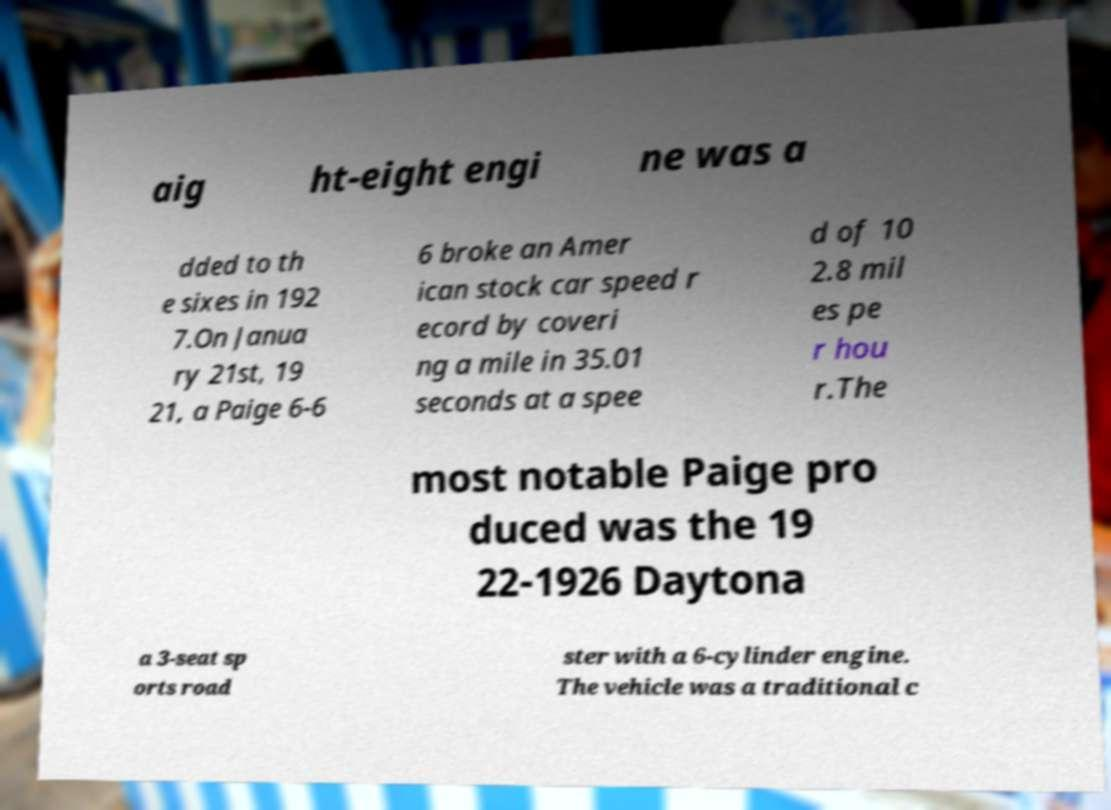Could you assist in decoding the text presented in this image and type it out clearly? aig ht-eight engi ne was a dded to th e sixes in 192 7.On Janua ry 21st, 19 21, a Paige 6-6 6 broke an Amer ican stock car speed r ecord by coveri ng a mile in 35.01 seconds at a spee d of 10 2.8 mil es pe r hou r.The most notable Paige pro duced was the 19 22-1926 Daytona a 3-seat sp orts road ster with a 6-cylinder engine. The vehicle was a traditional c 